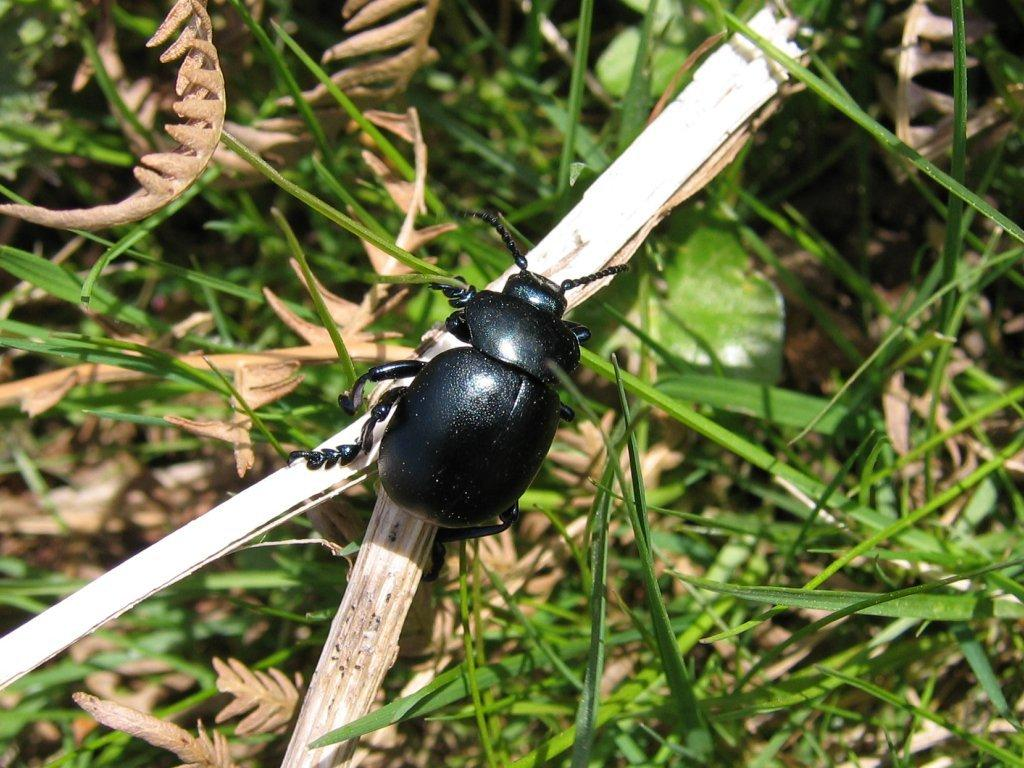What is on the stick in the image? There is an insect on a stick in the image. What type of vegetation can be seen in the image? There are leaves and grass in the image. What type of juice is being served in the image? There is no juice present in the image; it features an insect on a stick and vegetation. What role does society play in the image? There is no reference to society in the image, as it focuses on an insect and vegetation. 